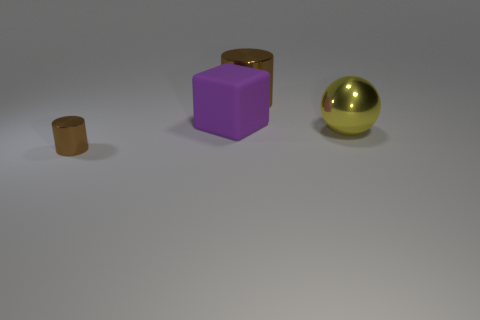Subtract all purple cylinders. Subtract all cyan blocks. How many cylinders are left? 2 Add 2 purple matte objects. How many objects exist? 6 Subtract all spheres. How many objects are left? 3 Add 1 tiny purple rubber objects. How many tiny purple rubber objects exist? 1 Subtract 0 blue cylinders. How many objects are left? 4 Subtract all big matte cubes. Subtract all large shiny spheres. How many objects are left? 2 Add 4 big shiny cylinders. How many big shiny cylinders are left? 5 